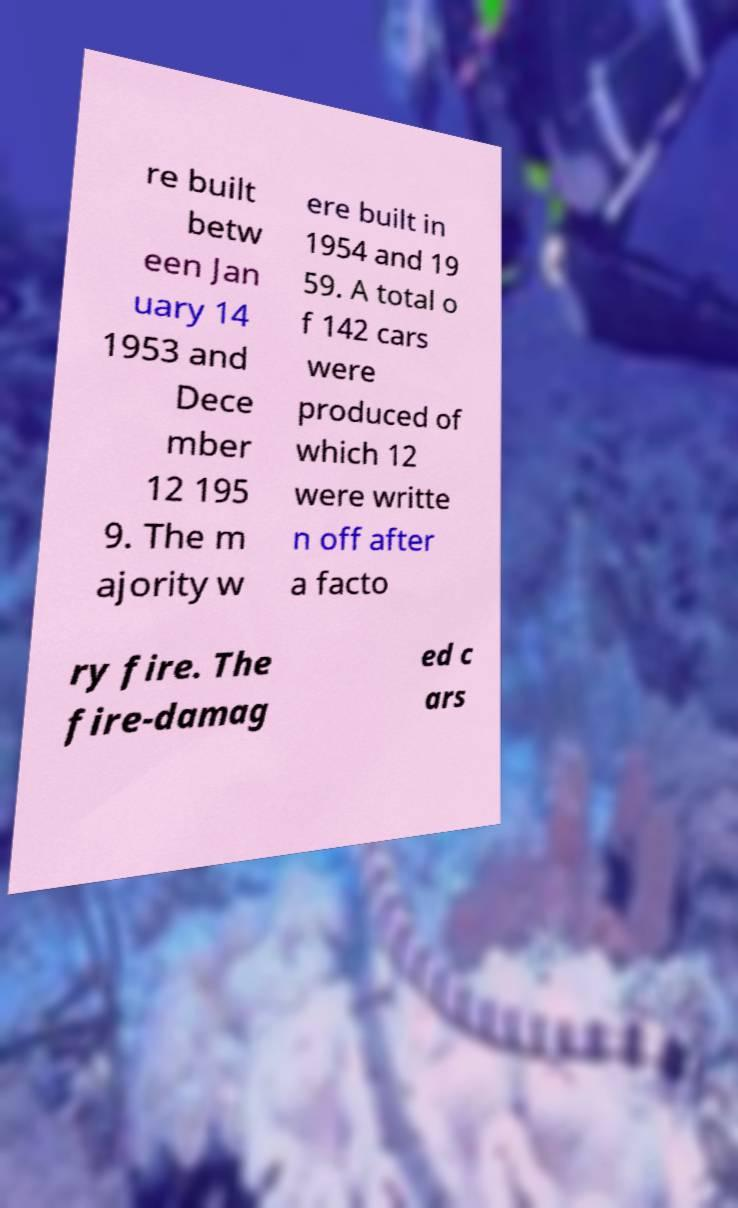Could you extract and type out the text from this image? re built betw een Jan uary 14 1953 and Dece mber 12 195 9. The m ajority w ere built in 1954 and 19 59. A total o f 142 cars were produced of which 12 were writte n off after a facto ry fire. The fire-damag ed c ars 